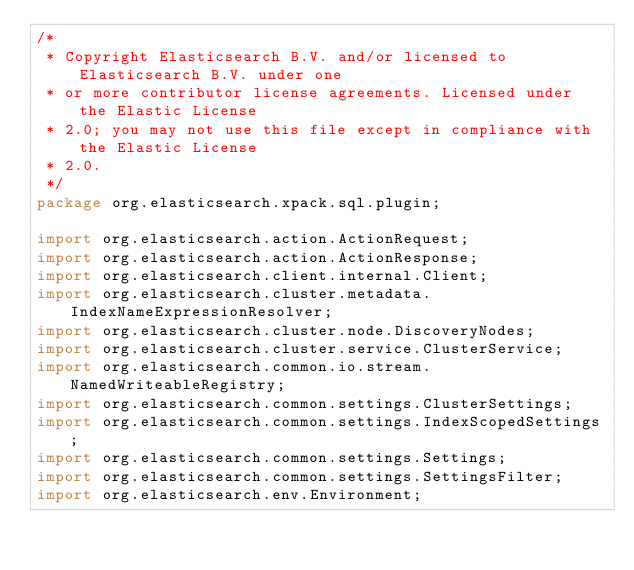<code> <loc_0><loc_0><loc_500><loc_500><_Java_>/*
 * Copyright Elasticsearch B.V. and/or licensed to Elasticsearch B.V. under one
 * or more contributor license agreements. Licensed under the Elastic License
 * 2.0; you may not use this file except in compliance with the Elastic License
 * 2.0.
 */
package org.elasticsearch.xpack.sql.plugin;

import org.elasticsearch.action.ActionRequest;
import org.elasticsearch.action.ActionResponse;
import org.elasticsearch.client.internal.Client;
import org.elasticsearch.cluster.metadata.IndexNameExpressionResolver;
import org.elasticsearch.cluster.node.DiscoveryNodes;
import org.elasticsearch.cluster.service.ClusterService;
import org.elasticsearch.common.io.stream.NamedWriteableRegistry;
import org.elasticsearch.common.settings.ClusterSettings;
import org.elasticsearch.common.settings.IndexScopedSettings;
import org.elasticsearch.common.settings.Settings;
import org.elasticsearch.common.settings.SettingsFilter;
import org.elasticsearch.env.Environment;</code> 